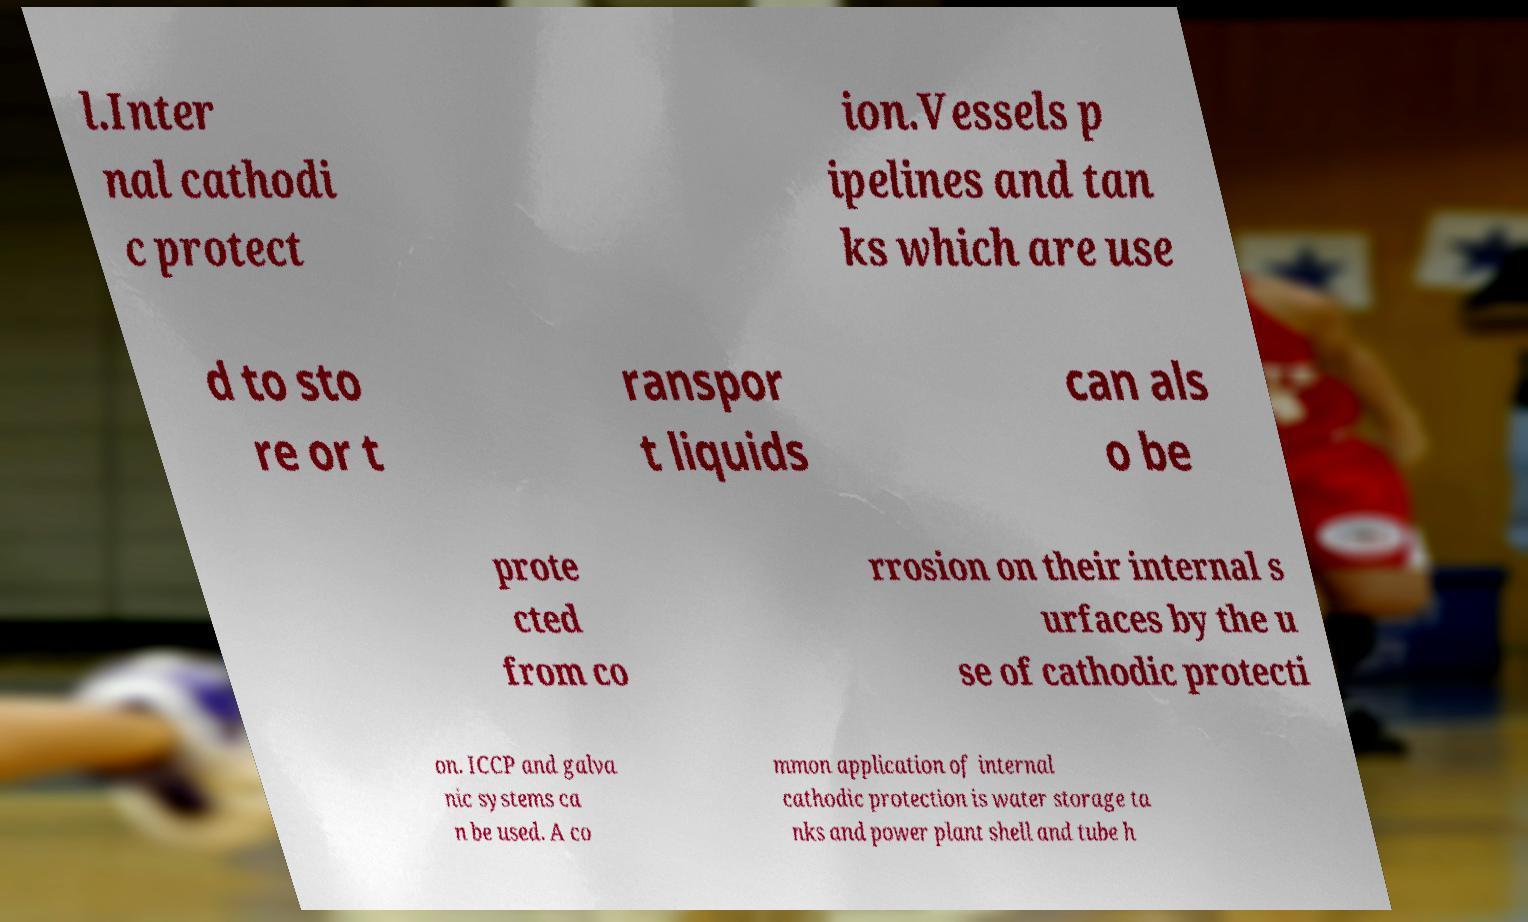I need the written content from this picture converted into text. Can you do that? l.Inter nal cathodi c protect ion.Vessels p ipelines and tan ks which are use d to sto re or t ranspor t liquids can als o be prote cted from co rrosion on their internal s urfaces by the u se of cathodic protecti on. ICCP and galva nic systems ca n be used. A co mmon application of internal cathodic protection is water storage ta nks and power plant shell and tube h 